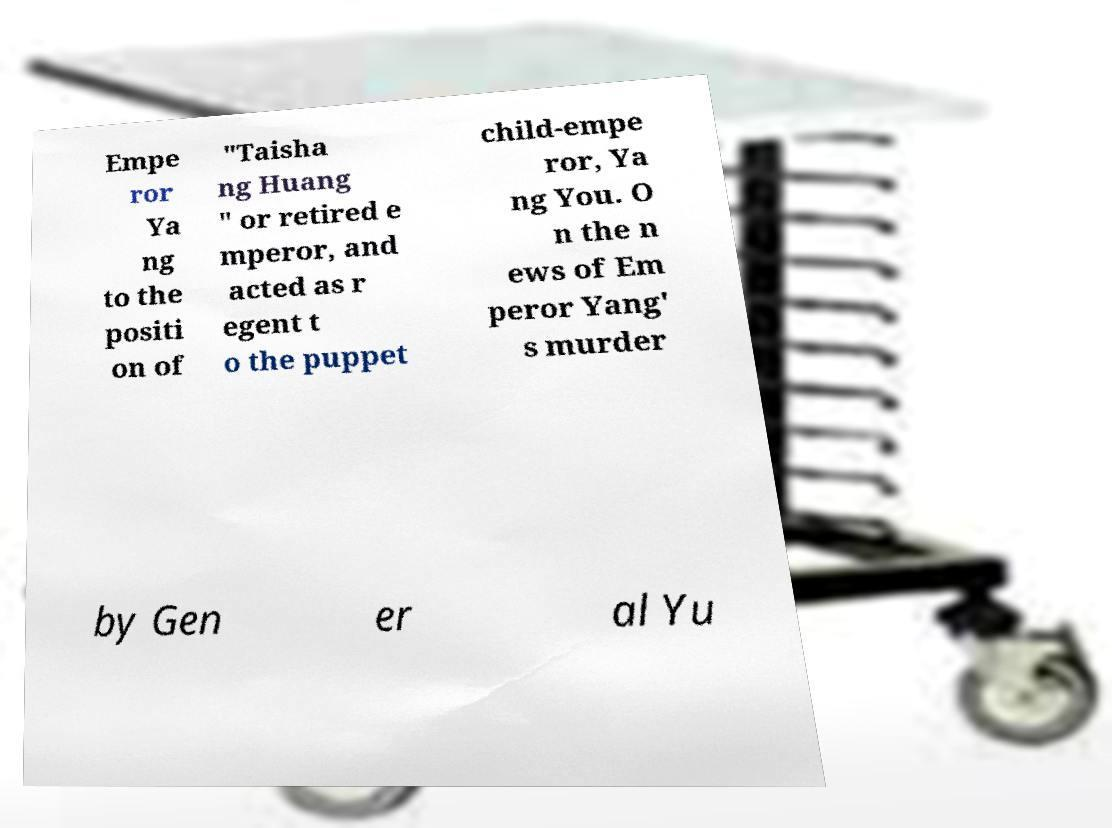Could you assist in decoding the text presented in this image and type it out clearly? Empe ror Ya ng to the positi on of "Taisha ng Huang " or retired e mperor, and acted as r egent t o the puppet child-empe ror, Ya ng You. O n the n ews of Em peror Yang' s murder by Gen er al Yu 